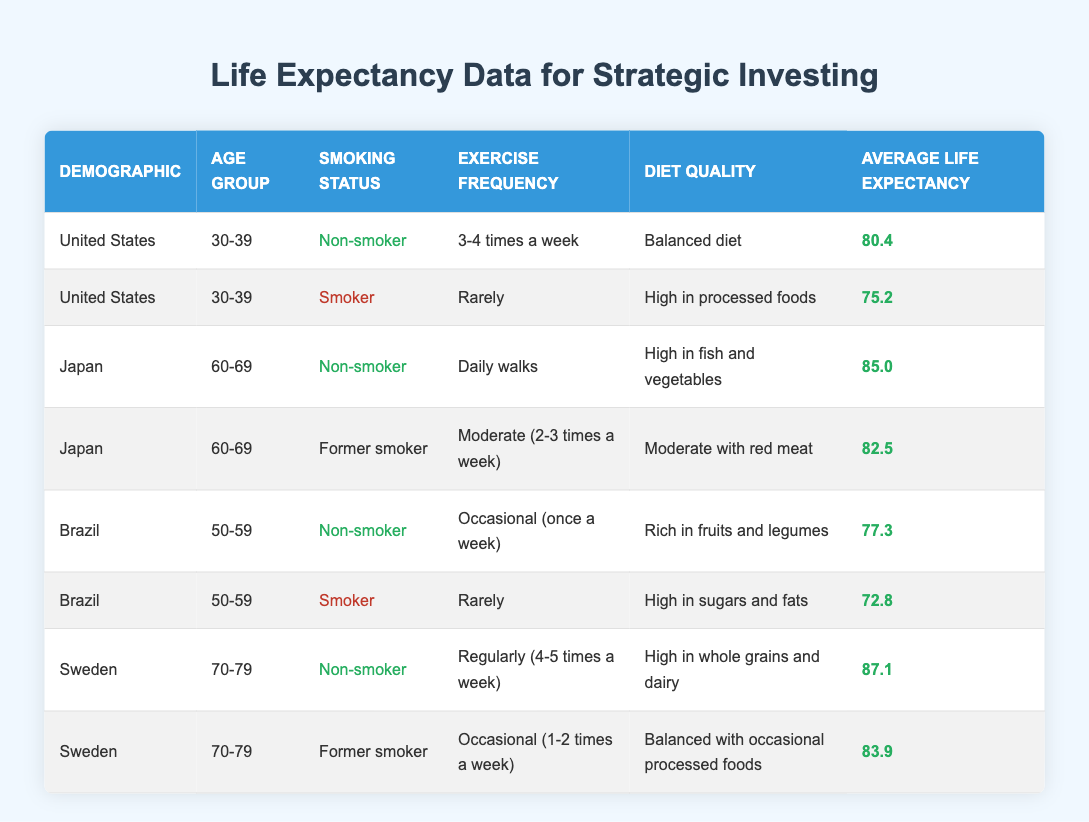What is the average life expectancy for non-smokers in the United States? To find the average life expectancy for non-smokers in the United States, we look at the relevant row in the table. There is one data point: 80.4 for the age group 30-39. Therefore, the average life expectancy for non-smokers in the United States is simply 80.4.
Answer: 80.4 How much longer, on average, do non-smokers in Sweden live compared to smokers in the same demographic? In Sweden, the non-smokers in the age group 70-79 have an average life expectancy of 87.1, while the former smokers in the same demography have an average of 83.9. To find the difference, we subtract 83.9 from 87.1, which results in 3.2 years.
Answer: 3.2 years Is the average life expectancy higher for smokers or non-smokers in Brazil? The data shows that non-smokers in Brazil have an average life expectancy of 77.3 while smokers have an average life expectancy of 72.8. Since 77.3 is higher than 72.8, the claim is true that non-smokers live longer than smokers in Brazil.
Answer: Yes What is the combined average life expectancy for all age groups in Japan? For Japan, we have data points for the age group 60-69. The non-smokers have an average life expectancy of 85.0 and former smokers have an average of 82.5. To calculate the combined average, we sum the two expectations and divide by the number of data points (2): (85.0 + 82.5) / 2 = 83.75.
Answer: 83.75 Which demographic has the highest average life expectancy and what is the value? From the table, we can see that Sweden's non-smokers in the age group 70-79 have the highest life expectancy at 87.1 years. No other demographic in the provided data surpasses this figure.
Answer: 87.1 How does the average life expectancy of 30-39-year-old smokers in the United States compare to that of 50-59-year-old non-smokers in Brazil? The average life expectancy for the 30-39-year-old smokers in the United States is 75.2, while the non-smokers in Brazil of the same age group have an average of 77.3. To compare them, we can see that 77.3 is greater than 75.2, which indicates that non-smokers in Brazil live longer than smokers in the U.S. within those respective age groups.
Answer: Non-smokers in Brazil live longer Do all non-smokers in the table live longer than all smokers? We check each demographic: non-smokers in the United States (80.4) and Japan (85.0), and Brazil (77.3) all have higher values than their smoker counterparts (smokers in the U.S. at 75.2, Japan at 82.5, and Brazil at 72.8). Since all non-smoker values are greater than the smoker values in the respective demographics, we conclude yes.
Answer: Yes What is the life expectancy difference between the best and the worst nonsmoker in the table? The best nonsmoker in the table is Sweden with a life expectancy of 87.1 years, and the worst nonsmoker is Brazil with 77.3 years. The difference is calculated as 87.1 - 77.3 = 9.8 years.
Answer: 9.8 years What percentage of the data points represent smokers? There are 8 data points in total, with 3 representing smokers (2 from Brazil and 1 from the U.S.). The percentage is (3 smokers / 8 total entries) * 100 = 37.5%.
Answer: 37.5% 